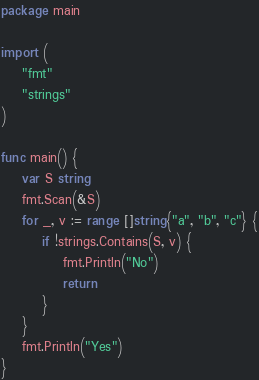Convert code to text. <code><loc_0><loc_0><loc_500><loc_500><_Go_>package main

import (
	"fmt"
	"strings"
)

func main() {
	var S string
	fmt.Scan(&S)
	for _, v := range []string{"a", "b", "c"} {
		if !strings.Contains(S, v) {
			fmt.Println("No")
			return
		}
	}
	fmt.Println("Yes")
}
</code> 